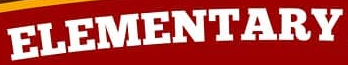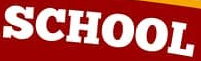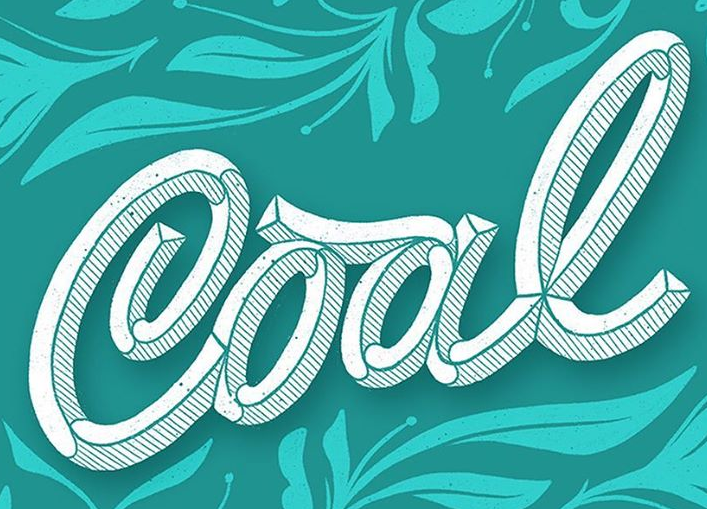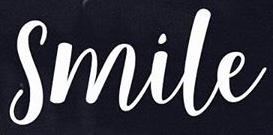Identify the words shown in these images in order, separated by a semicolon. ELEMENTARY; SCHOOL; Cool; Smile 